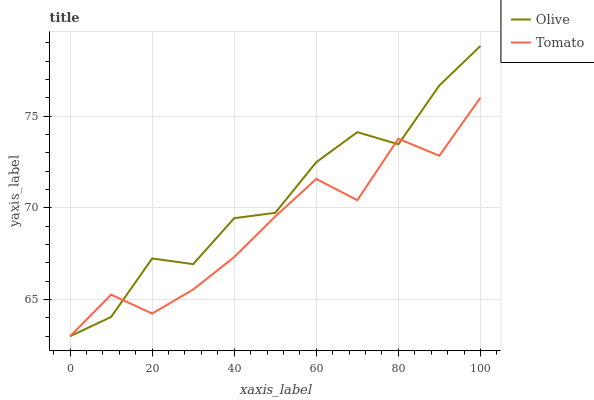Does Tomato have the minimum area under the curve?
Answer yes or no. Yes. Does Olive have the maximum area under the curve?
Answer yes or no. Yes. Does Tomato have the maximum area under the curve?
Answer yes or no. No. Is Olive the smoothest?
Answer yes or no. Yes. Is Tomato the roughest?
Answer yes or no. Yes. Is Tomato the smoothest?
Answer yes or no. No. Does Olive have the lowest value?
Answer yes or no. Yes. Does Olive have the highest value?
Answer yes or no. Yes. Does Tomato have the highest value?
Answer yes or no. No. Does Olive intersect Tomato?
Answer yes or no. Yes. Is Olive less than Tomato?
Answer yes or no. No. Is Olive greater than Tomato?
Answer yes or no. No. 